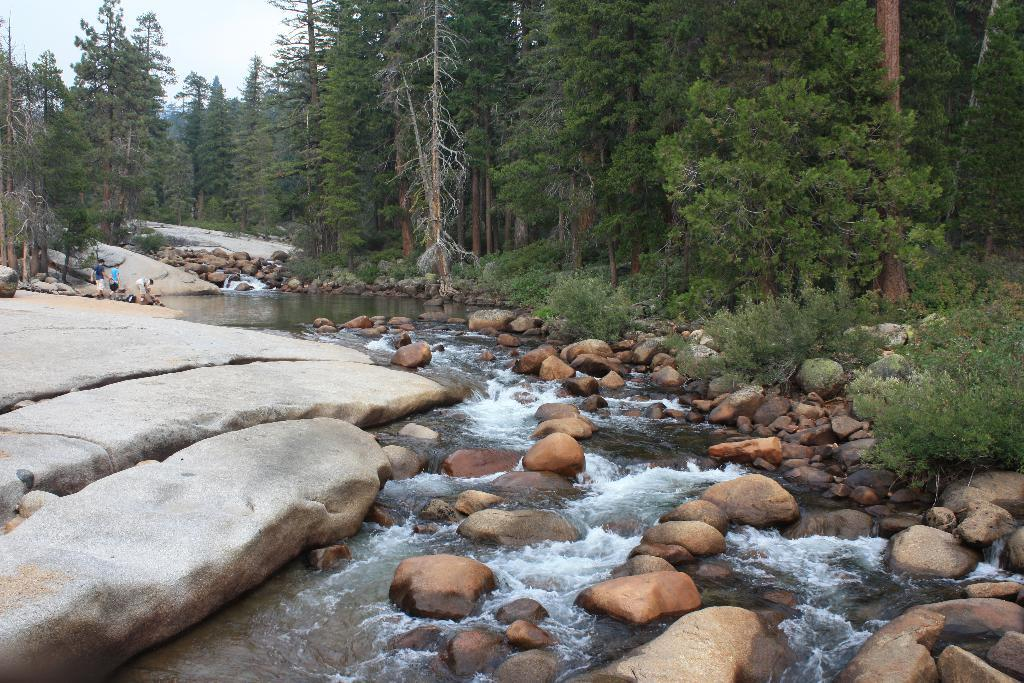What type of natural elements can be seen in the image? There are stones, plants, water, trees, and the sky visible in the image. Are there any living organisms present in the image? Yes, there are people in the image. Where are the people located in the image? The people are on rocks in the image. How do the people show respect to the lock in the image? There is no lock present in the image, so the question is not applicable. 